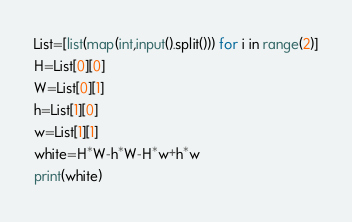<code> <loc_0><loc_0><loc_500><loc_500><_Python_>List=[list(map(int,input().split())) for i in range(2)]
H=List[0][0]
W=List[0][1]
h=List[1][0]
w=List[1][1]
white=H*W-h*W-H*w+h*w
print(white)</code> 